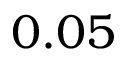Convert formula to latex. <formula><loc_0><loc_0><loc_500><loc_500>0 . 0 5</formula> 